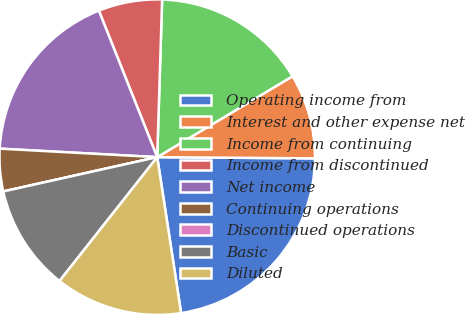<chart> <loc_0><loc_0><loc_500><loc_500><pie_chart><fcel>Operating income from<fcel>Interest and other expense net<fcel>Income from continuing<fcel>Income from discontinued<fcel>Net income<fcel>Continuing operations<fcel>Discontinued operations<fcel>Basic<fcel>Diluted<nl><fcel>22.46%<fcel>8.7%<fcel>15.93%<fcel>6.53%<fcel>18.11%<fcel>4.35%<fcel>0.0%<fcel>10.88%<fcel>13.05%<nl></chart> 